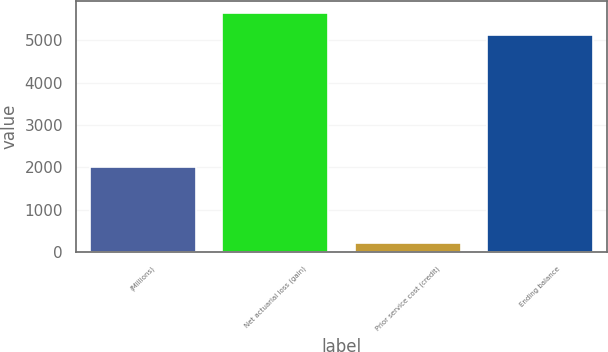<chart> <loc_0><loc_0><loc_500><loc_500><bar_chart><fcel>(Millions)<fcel>Net actuarial loss (gain)<fcel>Prior service cost (credit)<fcel>Ending balance<nl><fcel>2015<fcel>5652.9<fcel>227<fcel>5139<nl></chart> 